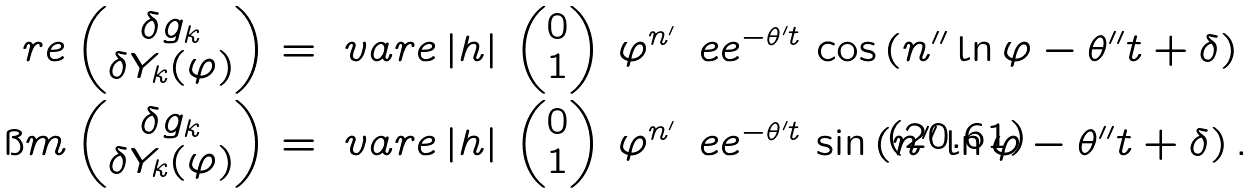Convert formula to latex. <formula><loc_0><loc_0><loc_500><loc_500>\ r e \begin{pmatrix} \delta g _ { k } \\ \delta Y _ { k } ( \varphi ) \end{pmatrix} & = \ v a r e \, | h | \, \begin{pmatrix} 0 \\ 1 \end{pmatrix} \, \varphi ^ { n ^ { \prime } } \, \ e e ^ { - \theta ^ { \prime } t } \, \cos \left ( n ^ { \prime \prime } \ln \varphi - \theta ^ { \prime \prime } t + \delta \right ) \\ \i m \begin{pmatrix} \delta g _ { k } \\ \delta Y _ { k } ( \varphi ) \end{pmatrix} & = \ v a r e \, | h | \, \begin{pmatrix} 0 \\ 1 \end{pmatrix} \, \varphi ^ { n ^ { \prime } } \, \ e e ^ { - \theta ^ { \prime } t } \, \sin \left ( n ^ { \prime \prime } \ln \varphi - \theta ^ { \prime \prime } t + \delta \right ) .</formula> 